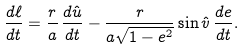Convert formula to latex. <formula><loc_0><loc_0><loc_500><loc_500>\frac { d \ell } { d t } = \frac { r } { a } \, \frac { d \hat { u } } { d t } - \frac { r } { a \sqrt { 1 - e ^ { 2 } } } \sin { \hat { v } } \, \frac { d e } { d t } .</formula> 